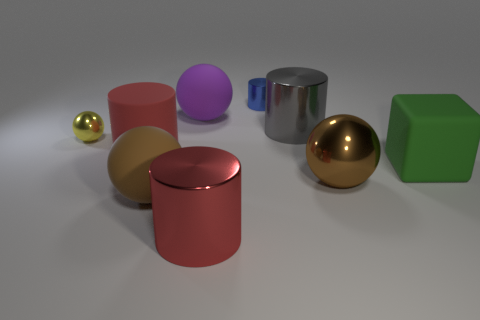What is the shape of the large matte thing that is behind the red matte cylinder? The shape of the large matte object behind the red matte cylinder is a sphere. It appears to be a sizeable, round three-dimensional object with an even surface, which indicates that it is a sphere rather than any other shape. 